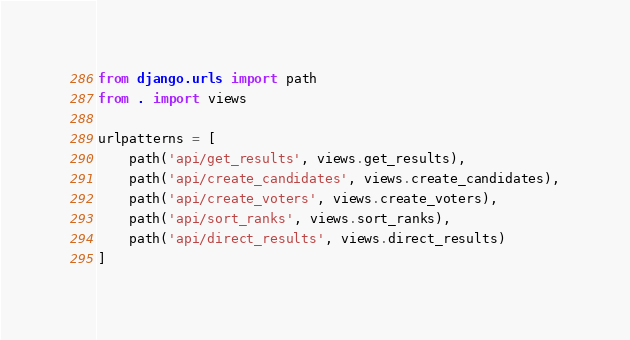<code> <loc_0><loc_0><loc_500><loc_500><_Python_>from django.urls import path
from . import views

urlpatterns = [
    path('api/get_results', views.get_results),
    path('api/create_candidates', views.create_candidates),
    path('api/create_voters', views.create_voters),
    path('api/sort_ranks', views.sort_ranks),
    path('api/direct_results', views.direct_results)
]</code> 